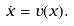<formula> <loc_0><loc_0><loc_500><loc_500>\dot { x } = { v } ( { x } ) .</formula> 